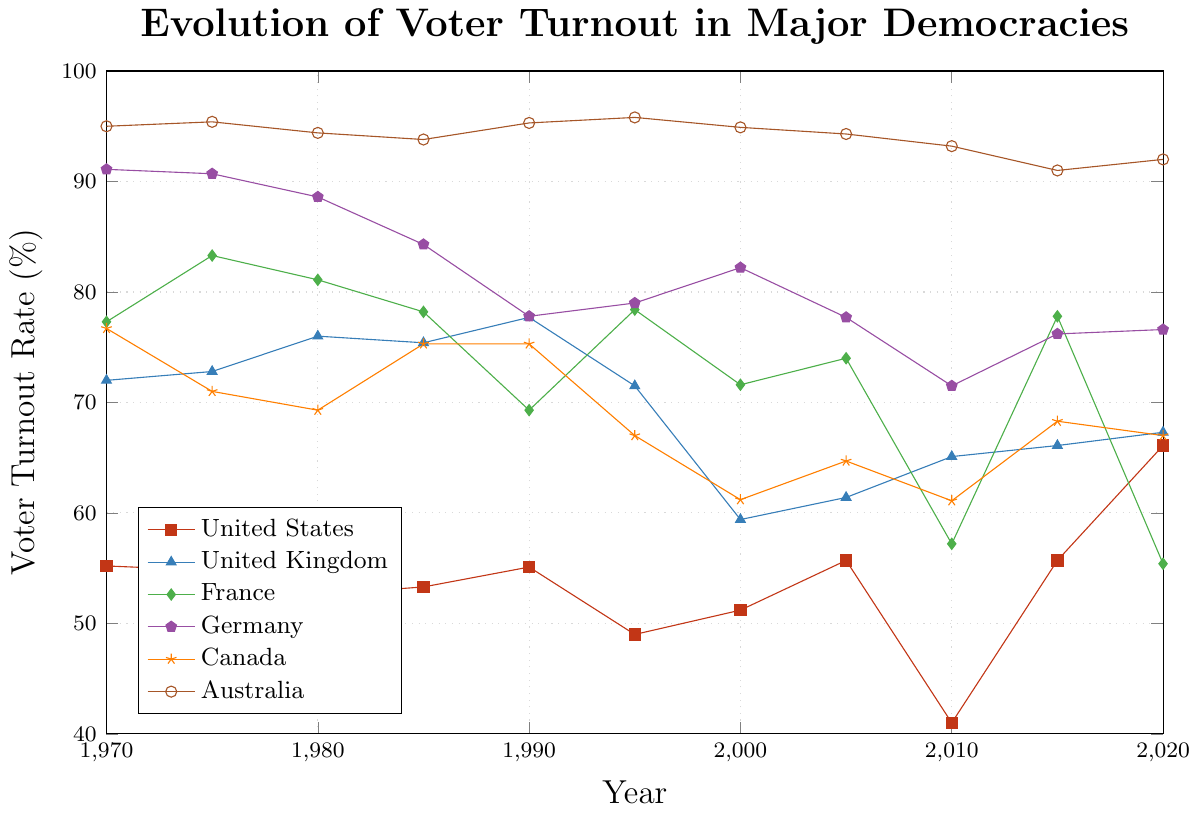What was the voter turnout rate for the United States in 2010? By visually inspecting the line corresponding to the United States, look for the value at the 2010 marker.
Answer: 41.0% Which country had the highest voter turnout rate in 2020? Observe all the lines at the 2020 marker and identify the line that reaches the highest point.
Answer: Germany Between 1980 and 2000, which country experienced the largest drop in voter turnout? Calculate the difference in voter turnout rates for all the countries between 1980 and 2000, then identify the one with the largest negative change.
Answer: United Kingdom In what year did France experience its lowest voter turnout and what was the rate? Check the line corresponding to France and find the lowest point, then identify the year and the turnout rate.
Answer: 2010, 57.2% How did the voter turnout rates for Canada and the United States compare in 1970? Look at the initial values for both countries in 1970 and compare them.
Answer: Canada was higher than the United States What is the average voter turnout rate for Germany from 1970 to 2020? Sum the voter turnout rates for Germany over the years and divide by the number of data points to find the average.
Answer: ~81.6% Did Australia’s voter turnout rate ever fall below 90%? Analyze the line for Australia and check if it ever goes below the 90% line.
Answer: No Which decade saw the greatest decline in voter turnout for the United Kingdom? Compare the changes in voter turnout for the United Kingdom across each decade, find the decade with the greatest decline.
Answer: Between 1990 and 2000 By how much did the voter turnout rate in the United States increase from 2010 to 2020? Subtract the voter turnout rate in 2010 from that in 2020 for the United States.
Answer: 25.1% Which countries had a voter turnout rate above 70% in 1990? Identify the countries whose lines are above the 70% marker in the year 1990.
Answer: United Kingdom, France, Germany, Canada, Australia 